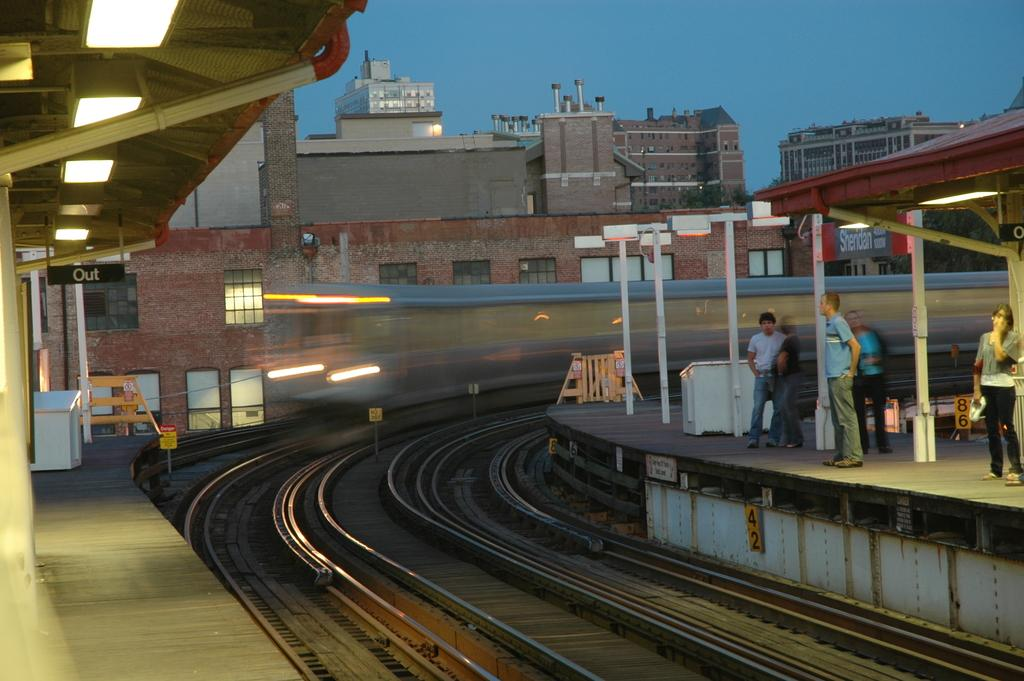What type of transportation infrastructure is present in the image? There is a railway track in the image. What else can be seen in the image besides the railway track? There are buildings and people visible in the image. What is visible at the top of the image? The sky is visible at the top of the image. How many clovers can be seen growing near the railway track in the image? There are no clovers visible in the image; it features a railway track, buildings, people, and the sky. What type of wish can be granted by the people in the image? There is no mention of wishes or any magical elements in the image; it simply shows a railway track, buildings, people, and the sky. 